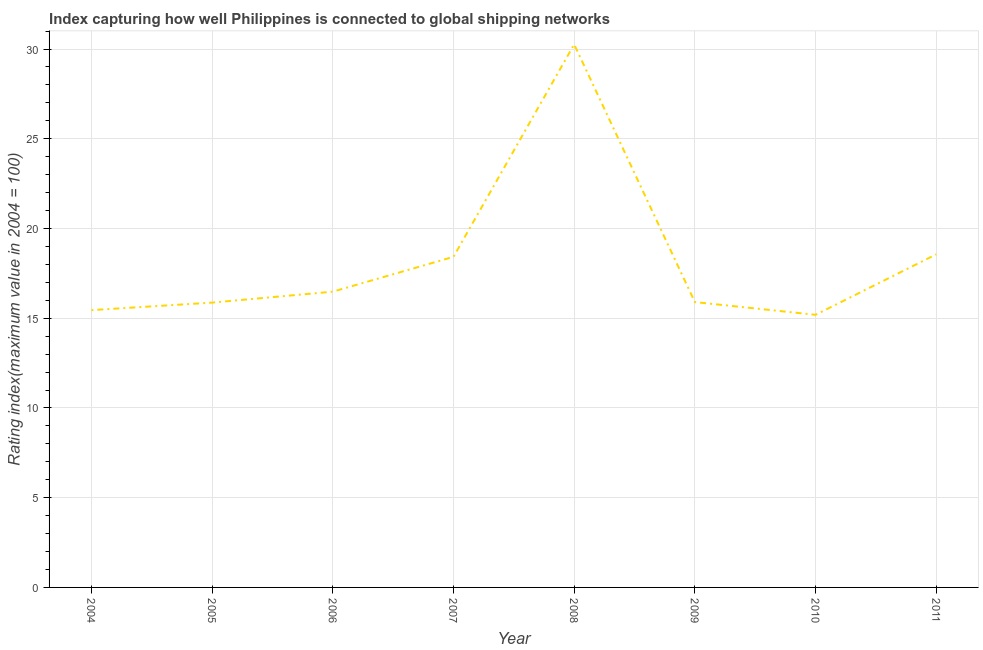What is the liner shipping connectivity index in 2006?
Your answer should be very brief. 16.48. Across all years, what is the maximum liner shipping connectivity index?
Offer a very short reply. 30.26. Across all years, what is the minimum liner shipping connectivity index?
Your answer should be very brief. 15.19. In which year was the liner shipping connectivity index maximum?
Provide a succinct answer. 2008. In which year was the liner shipping connectivity index minimum?
Your response must be concise. 2010. What is the sum of the liner shipping connectivity index?
Make the answer very short. 146.13. What is the difference between the liner shipping connectivity index in 2007 and 2010?
Offer a terse response. 3.23. What is the average liner shipping connectivity index per year?
Your answer should be compact. 18.27. What is the median liner shipping connectivity index?
Your answer should be very brief. 16.19. In how many years, is the liner shipping connectivity index greater than 22 ?
Your answer should be very brief. 1. Do a majority of the years between 2011 and 2007 (inclusive) have liner shipping connectivity index greater than 6 ?
Your answer should be compact. Yes. What is the ratio of the liner shipping connectivity index in 2005 to that in 2007?
Give a very brief answer. 0.86. What is the difference between the highest and the second highest liner shipping connectivity index?
Provide a succinct answer. 11.7. What is the difference between the highest and the lowest liner shipping connectivity index?
Offer a terse response. 15.07. In how many years, is the liner shipping connectivity index greater than the average liner shipping connectivity index taken over all years?
Provide a short and direct response. 3. How many lines are there?
Your answer should be compact. 1. Are the values on the major ticks of Y-axis written in scientific E-notation?
Offer a very short reply. No. Does the graph contain grids?
Your response must be concise. Yes. What is the title of the graph?
Provide a succinct answer. Index capturing how well Philippines is connected to global shipping networks. What is the label or title of the X-axis?
Offer a very short reply. Year. What is the label or title of the Y-axis?
Your answer should be very brief. Rating index(maximum value in 2004 = 100). What is the Rating index(maximum value in 2004 = 100) of 2004?
Offer a terse response. 15.45. What is the Rating index(maximum value in 2004 = 100) in 2005?
Your answer should be compact. 15.87. What is the Rating index(maximum value in 2004 = 100) in 2006?
Offer a terse response. 16.48. What is the Rating index(maximum value in 2004 = 100) in 2007?
Ensure brevity in your answer.  18.42. What is the Rating index(maximum value in 2004 = 100) in 2008?
Offer a very short reply. 30.26. What is the Rating index(maximum value in 2004 = 100) in 2009?
Provide a succinct answer. 15.9. What is the Rating index(maximum value in 2004 = 100) of 2010?
Your answer should be very brief. 15.19. What is the Rating index(maximum value in 2004 = 100) in 2011?
Your answer should be compact. 18.56. What is the difference between the Rating index(maximum value in 2004 = 100) in 2004 and 2005?
Make the answer very short. -0.42. What is the difference between the Rating index(maximum value in 2004 = 100) in 2004 and 2006?
Ensure brevity in your answer.  -1.03. What is the difference between the Rating index(maximum value in 2004 = 100) in 2004 and 2007?
Provide a short and direct response. -2.97. What is the difference between the Rating index(maximum value in 2004 = 100) in 2004 and 2008?
Keep it short and to the point. -14.81. What is the difference between the Rating index(maximum value in 2004 = 100) in 2004 and 2009?
Give a very brief answer. -0.45. What is the difference between the Rating index(maximum value in 2004 = 100) in 2004 and 2010?
Give a very brief answer. 0.26. What is the difference between the Rating index(maximum value in 2004 = 100) in 2004 and 2011?
Give a very brief answer. -3.11. What is the difference between the Rating index(maximum value in 2004 = 100) in 2005 and 2006?
Make the answer very short. -0.61. What is the difference between the Rating index(maximum value in 2004 = 100) in 2005 and 2007?
Keep it short and to the point. -2.55. What is the difference between the Rating index(maximum value in 2004 = 100) in 2005 and 2008?
Keep it short and to the point. -14.39. What is the difference between the Rating index(maximum value in 2004 = 100) in 2005 and 2009?
Provide a succinct answer. -0.03. What is the difference between the Rating index(maximum value in 2004 = 100) in 2005 and 2010?
Give a very brief answer. 0.68. What is the difference between the Rating index(maximum value in 2004 = 100) in 2005 and 2011?
Make the answer very short. -2.69. What is the difference between the Rating index(maximum value in 2004 = 100) in 2006 and 2007?
Your answer should be compact. -1.94. What is the difference between the Rating index(maximum value in 2004 = 100) in 2006 and 2008?
Your response must be concise. -13.78. What is the difference between the Rating index(maximum value in 2004 = 100) in 2006 and 2009?
Offer a very short reply. 0.58. What is the difference between the Rating index(maximum value in 2004 = 100) in 2006 and 2010?
Provide a short and direct response. 1.29. What is the difference between the Rating index(maximum value in 2004 = 100) in 2006 and 2011?
Give a very brief answer. -2.08. What is the difference between the Rating index(maximum value in 2004 = 100) in 2007 and 2008?
Provide a succinct answer. -11.84. What is the difference between the Rating index(maximum value in 2004 = 100) in 2007 and 2009?
Keep it short and to the point. 2.52. What is the difference between the Rating index(maximum value in 2004 = 100) in 2007 and 2010?
Offer a terse response. 3.23. What is the difference between the Rating index(maximum value in 2004 = 100) in 2007 and 2011?
Offer a terse response. -0.14. What is the difference between the Rating index(maximum value in 2004 = 100) in 2008 and 2009?
Ensure brevity in your answer.  14.36. What is the difference between the Rating index(maximum value in 2004 = 100) in 2008 and 2010?
Offer a very short reply. 15.07. What is the difference between the Rating index(maximum value in 2004 = 100) in 2008 and 2011?
Ensure brevity in your answer.  11.7. What is the difference between the Rating index(maximum value in 2004 = 100) in 2009 and 2010?
Ensure brevity in your answer.  0.71. What is the difference between the Rating index(maximum value in 2004 = 100) in 2009 and 2011?
Provide a succinct answer. -2.66. What is the difference between the Rating index(maximum value in 2004 = 100) in 2010 and 2011?
Ensure brevity in your answer.  -3.37. What is the ratio of the Rating index(maximum value in 2004 = 100) in 2004 to that in 2005?
Provide a succinct answer. 0.97. What is the ratio of the Rating index(maximum value in 2004 = 100) in 2004 to that in 2006?
Ensure brevity in your answer.  0.94. What is the ratio of the Rating index(maximum value in 2004 = 100) in 2004 to that in 2007?
Make the answer very short. 0.84. What is the ratio of the Rating index(maximum value in 2004 = 100) in 2004 to that in 2008?
Your response must be concise. 0.51. What is the ratio of the Rating index(maximum value in 2004 = 100) in 2004 to that in 2011?
Your answer should be very brief. 0.83. What is the ratio of the Rating index(maximum value in 2004 = 100) in 2005 to that in 2006?
Ensure brevity in your answer.  0.96. What is the ratio of the Rating index(maximum value in 2004 = 100) in 2005 to that in 2007?
Your answer should be very brief. 0.86. What is the ratio of the Rating index(maximum value in 2004 = 100) in 2005 to that in 2008?
Offer a very short reply. 0.52. What is the ratio of the Rating index(maximum value in 2004 = 100) in 2005 to that in 2010?
Give a very brief answer. 1.04. What is the ratio of the Rating index(maximum value in 2004 = 100) in 2005 to that in 2011?
Give a very brief answer. 0.85. What is the ratio of the Rating index(maximum value in 2004 = 100) in 2006 to that in 2007?
Keep it short and to the point. 0.9. What is the ratio of the Rating index(maximum value in 2004 = 100) in 2006 to that in 2008?
Offer a very short reply. 0.55. What is the ratio of the Rating index(maximum value in 2004 = 100) in 2006 to that in 2009?
Provide a short and direct response. 1.04. What is the ratio of the Rating index(maximum value in 2004 = 100) in 2006 to that in 2010?
Keep it short and to the point. 1.08. What is the ratio of the Rating index(maximum value in 2004 = 100) in 2006 to that in 2011?
Ensure brevity in your answer.  0.89. What is the ratio of the Rating index(maximum value in 2004 = 100) in 2007 to that in 2008?
Offer a very short reply. 0.61. What is the ratio of the Rating index(maximum value in 2004 = 100) in 2007 to that in 2009?
Give a very brief answer. 1.16. What is the ratio of the Rating index(maximum value in 2004 = 100) in 2007 to that in 2010?
Provide a short and direct response. 1.21. What is the ratio of the Rating index(maximum value in 2004 = 100) in 2008 to that in 2009?
Your answer should be compact. 1.9. What is the ratio of the Rating index(maximum value in 2004 = 100) in 2008 to that in 2010?
Give a very brief answer. 1.99. What is the ratio of the Rating index(maximum value in 2004 = 100) in 2008 to that in 2011?
Provide a succinct answer. 1.63. What is the ratio of the Rating index(maximum value in 2004 = 100) in 2009 to that in 2010?
Offer a very short reply. 1.05. What is the ratio of the Rating index(maximum value in 2004 = 100) in 2009 to that in 2011?
Your answer should be very brief. 0.86. What is the ratio of the Rating index(maximum value in 2004 = 100) in 2010 to that in 2011?
Your response must be concise. 0.82. 